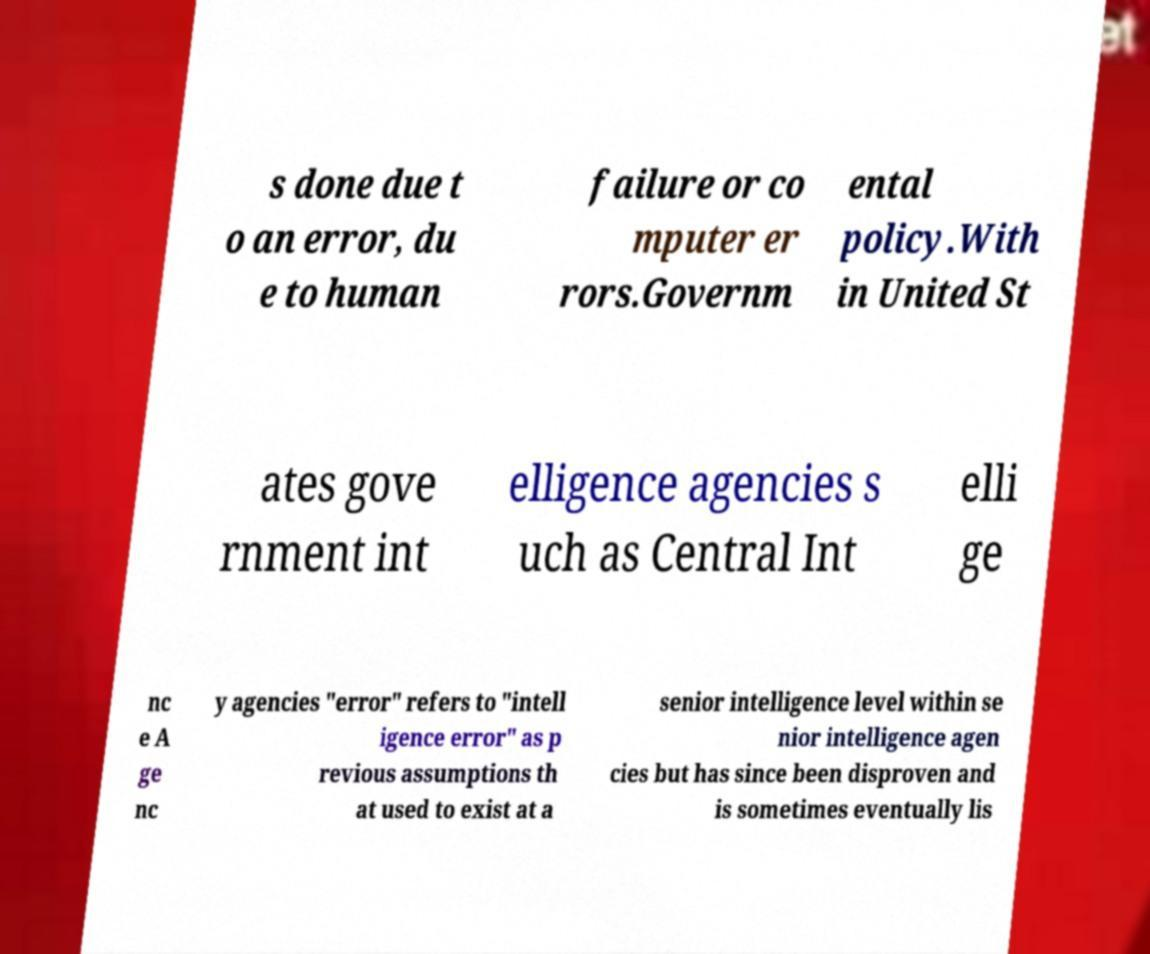Can you accurately transcribe the text from the provided image for me? s done due t o an error, du e to human failure or co mputer er rors.Governm ental policy.With in United St ates gove rnment int elligence agencies s uch as Central Int elli ge nc e A ge nc y agencies "error" refers to "intell igence error" as p revious assumptions th at used to exist at a senior intelligence level within se nior intelligence agen cies but has since been disproven and is sometimes eventually lis 